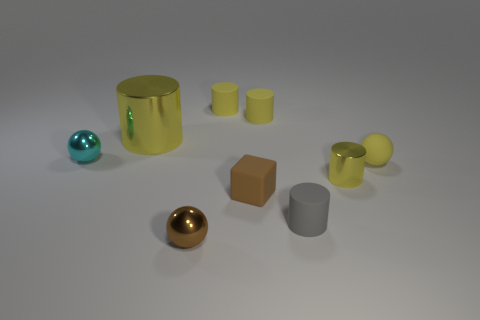Is there anything else that has the same material as the small cyan object?
Provide a short and direct response. Yes. There is a small yellow matte object that is in front of the big yellow thing; does it have the same shape as the yellow shiny thing that is in front of the big yellow metallic cylinder?
Give a very brief answer. No. Is the number of gray rubber cylinders that are in front of the brown metal ball less than the number of tiny cyan shiny things?
Your answer should be compact. Yes. How many big cylinders have the same color as the small matte block?
Your answer should be very brief. 0. What size is the metal cylinder that is in front of the small cyan sphere?
Your response must be concise. Small. The yellow shiny object on the left side of the tiny rubber cylinder that is in front of the tiny metal sphere that is on the left side of the big shiny cylinder is what shape?
Provide a short and direct response. Cylinder. What is the shape of the small yellow thing that is both to the right of the tiny gray cylinder and behind the tiny metal cylinder?
Make the answer very short. Sphere. Are there any metal cylinders that have the same size as the cyan metallic sphere?
Make the answer very short. Yes. There is a tiny yellow rubber object that is in front of the cyan thing; is its shape the same as the tiny gray rubber thing?
Offer a very short reply. No. Do the big shiny object and the small cyan metal object have the same shape?
Offer a very short reply. No. 